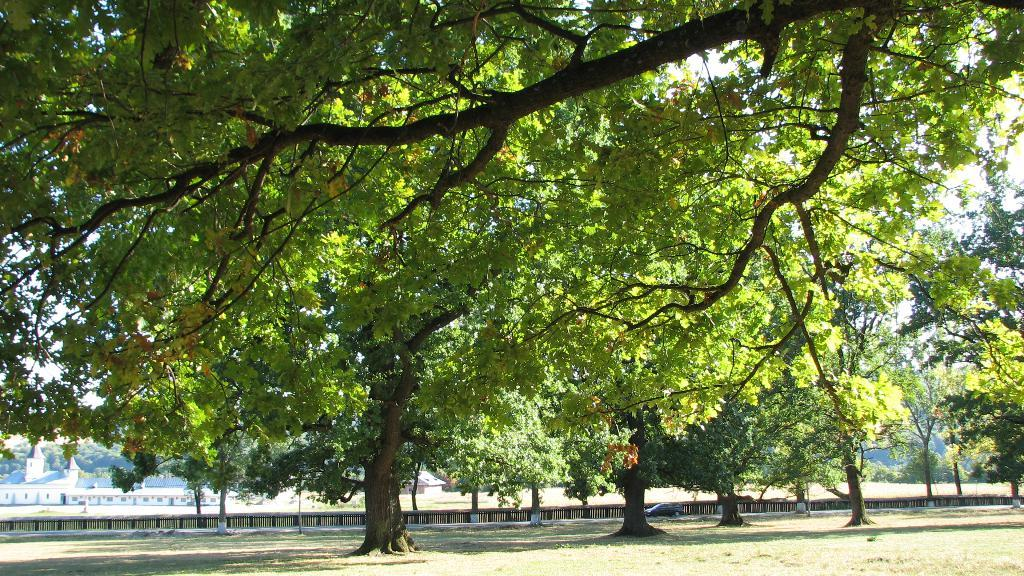What type of vegetation is present in the image? There is grass and trees in the image. What can be seen on the road in the image? There is a car on the road in the image. What structures are visible in the background of the image? There are houses and trees in the background of the image. What part of the natural environment is visible in the image? The sky is visible in the background of the image. How many chickens are visible in the image? There are no chickens present in the image. What grade of paper is used for the trees in the image? The trees in the image are real, and therefore not made of paper. 